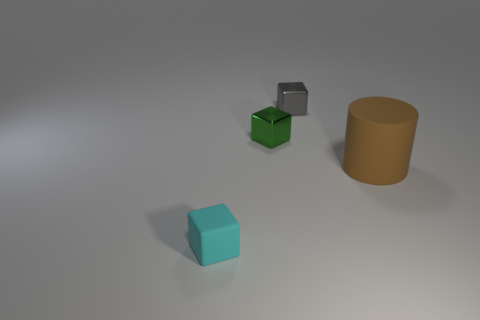Add 3 small gray metal blocks. How many objects exist? 7 Subtract all cylinders. How many objects are left? 3 Add 2 tiny blue metallic objects. How many tiny blue metallic objects exist? 2 Subtract 0 blue cylinders. How many objects are left? 4 Subtract all big purple matte balls. Subtract all gray objects. How many objects are left? 3 Add 4 big matte cylinders. How many big matte cylinders are left? 5 